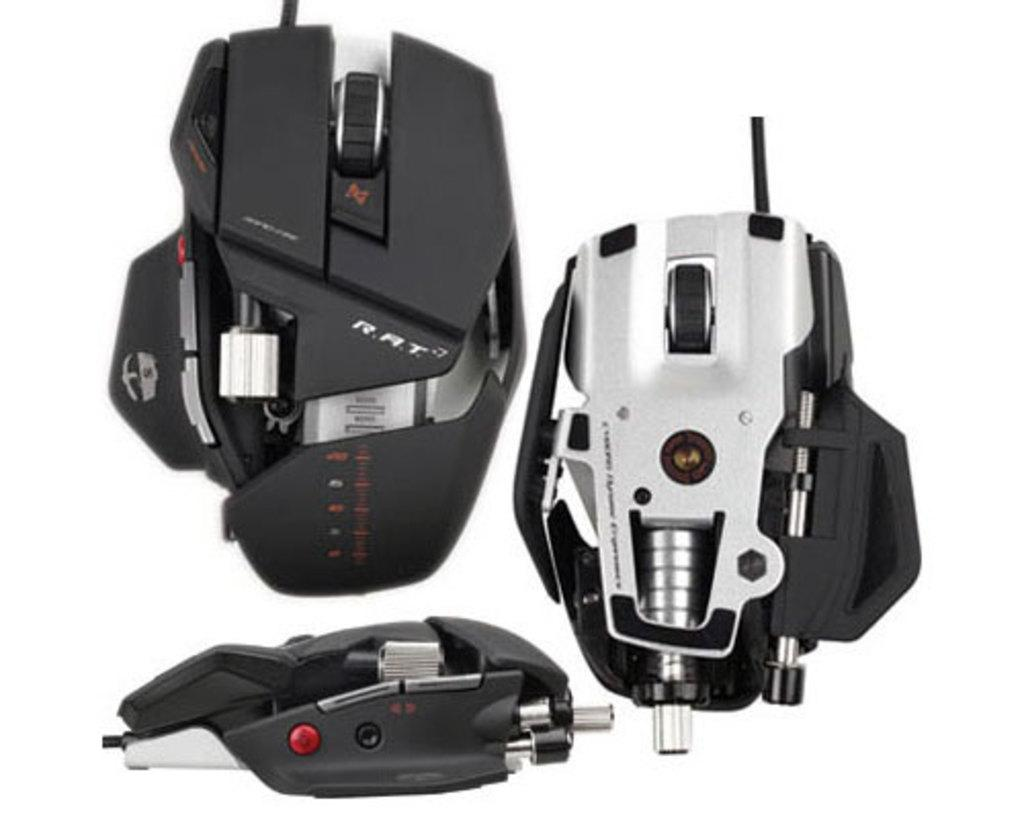What type of objects are in the image? There are gaming mouses in the image. Can you describe the purpose of these objects? The gaming mouses are designed for use in computer gaming. Are there any other related objects visible in the image? The provided facts do not mention any other related objects. What type of agreement is being signed on the steel table in the image? There is no agreement or steel table present in the image; it features gaming mouses. 